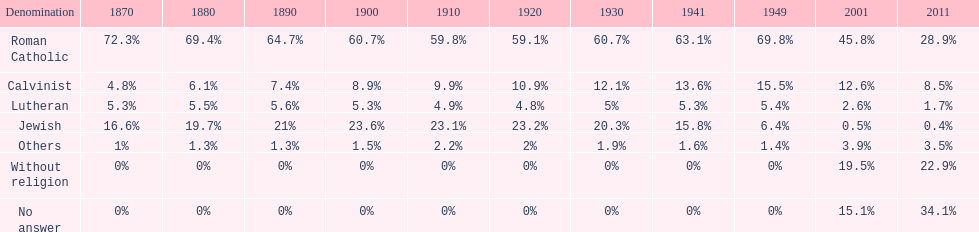The percentage of people who identified as calvinist was, at most, how much? 15.5%. 